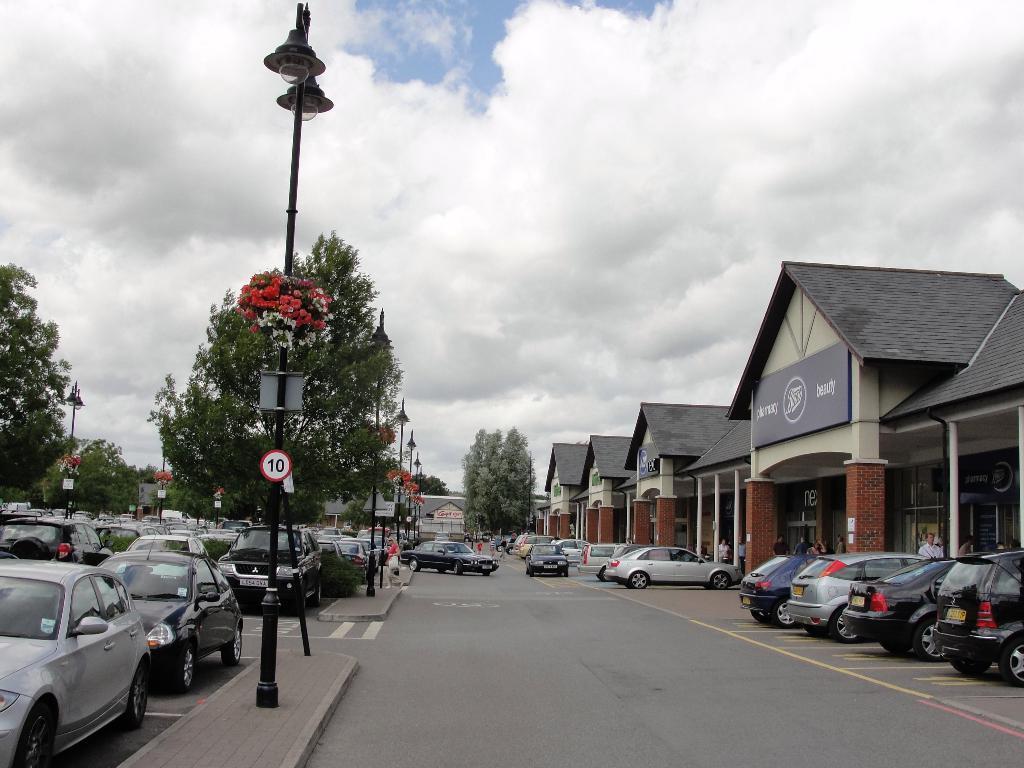Can you describe this image briefly? In the picture I can see these vehicles are parked on the road, I can see light poles, boards, trees, houses and the sky with clouds in the background. 